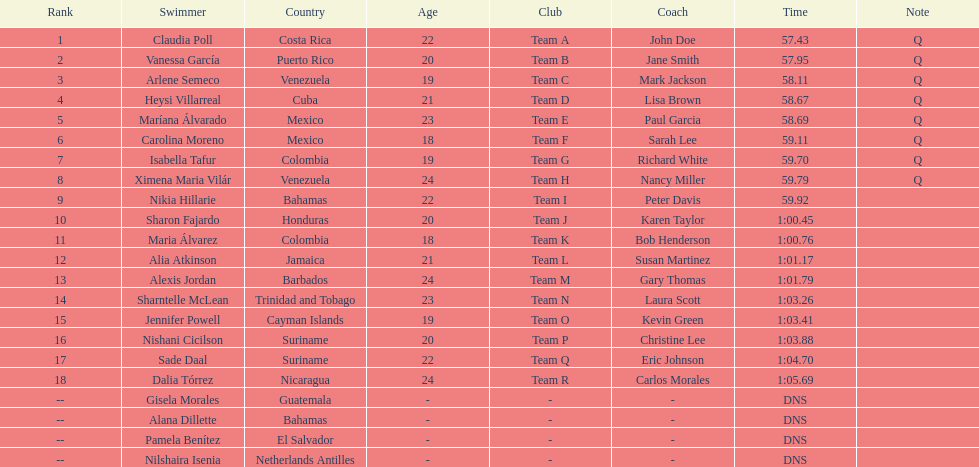What was claudia roll's time? 57.43. 